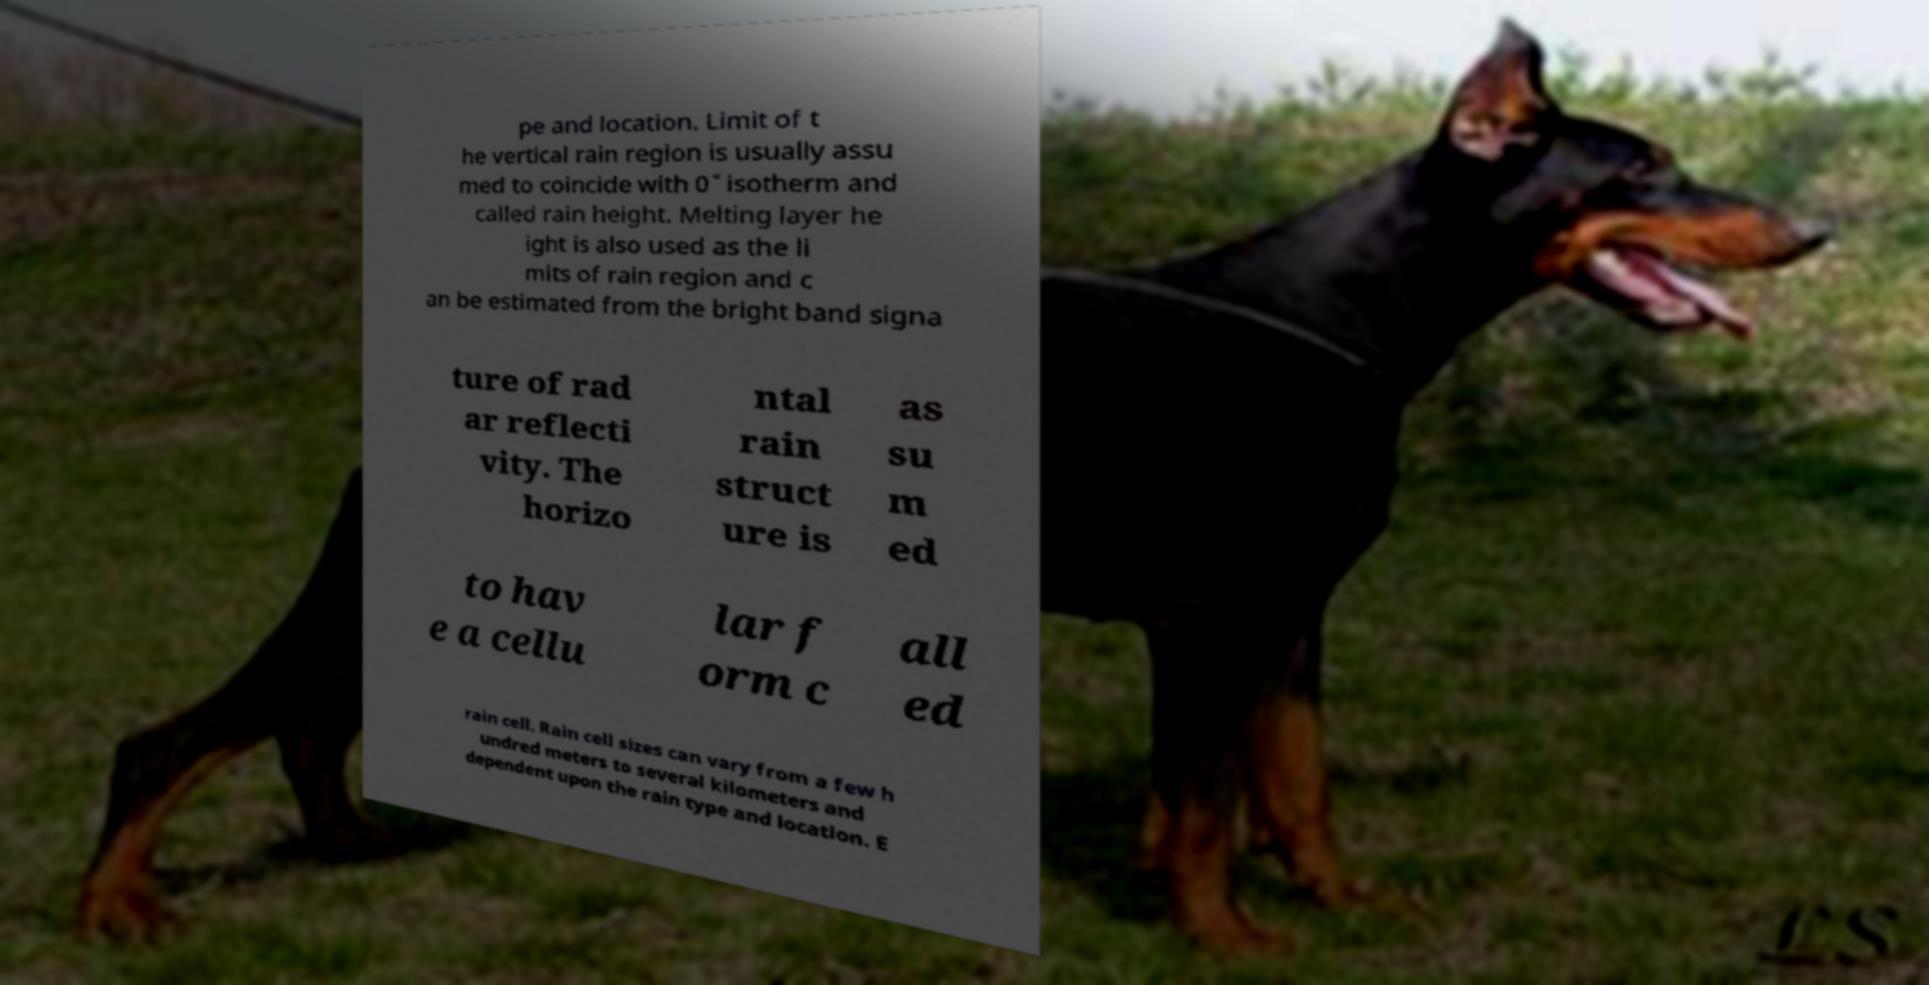Please read and relay the text visible in this image. What does it say? pe and location. Limit of t he vertical rain region is usually assu med to coincide with 0˚ isotherm and called rain height. Melting layer he ight is also used as the li mits of rain region and c an be estimated from the bright band signa ture of rad ar reflecti vity. The horizo ntal rain struct ure is as su m ed to hav e a cellu lar f orm c all ed rain cell. Rain cell sizes can vary from a few h undred meters to several kilometers and dependent upon the rain type and location. E 